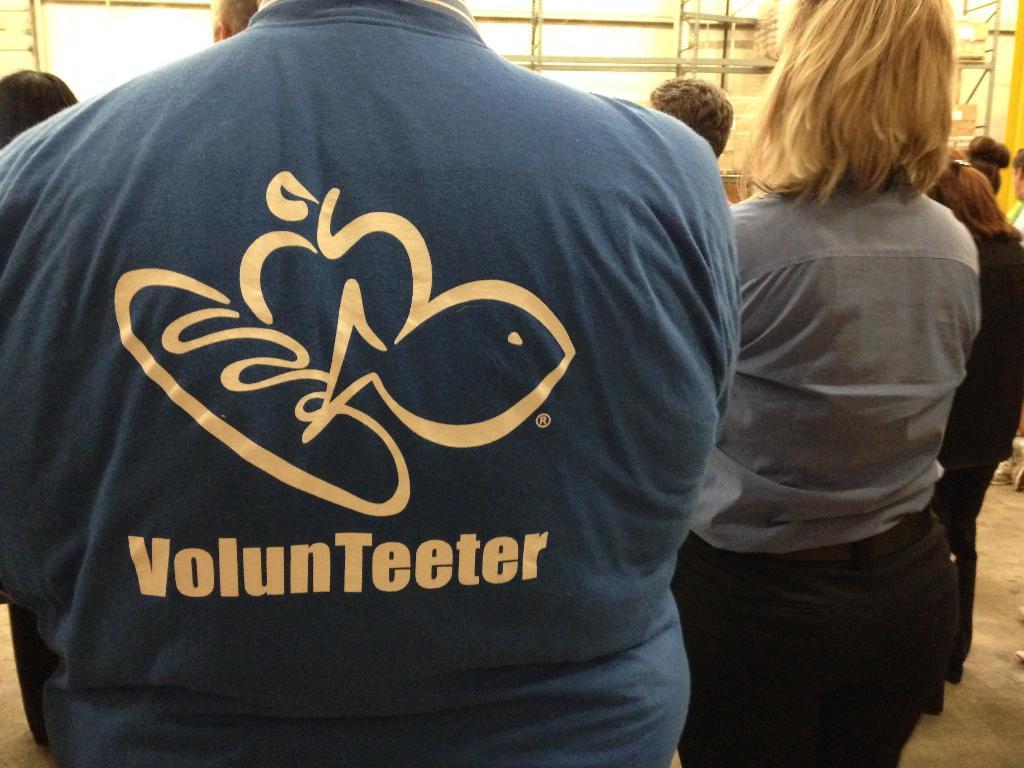What is the man in the green shirt?
Give a very brief answer. Volunteeter. What is the brand on the tee?
Give a very brief answer. Volunteeter. 